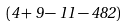Convert formula to latex. <formula><loc_0><loc_0><loc_500><loc_500>( 4 + 9 - 1 1 - 4 8 2 )</formula> 